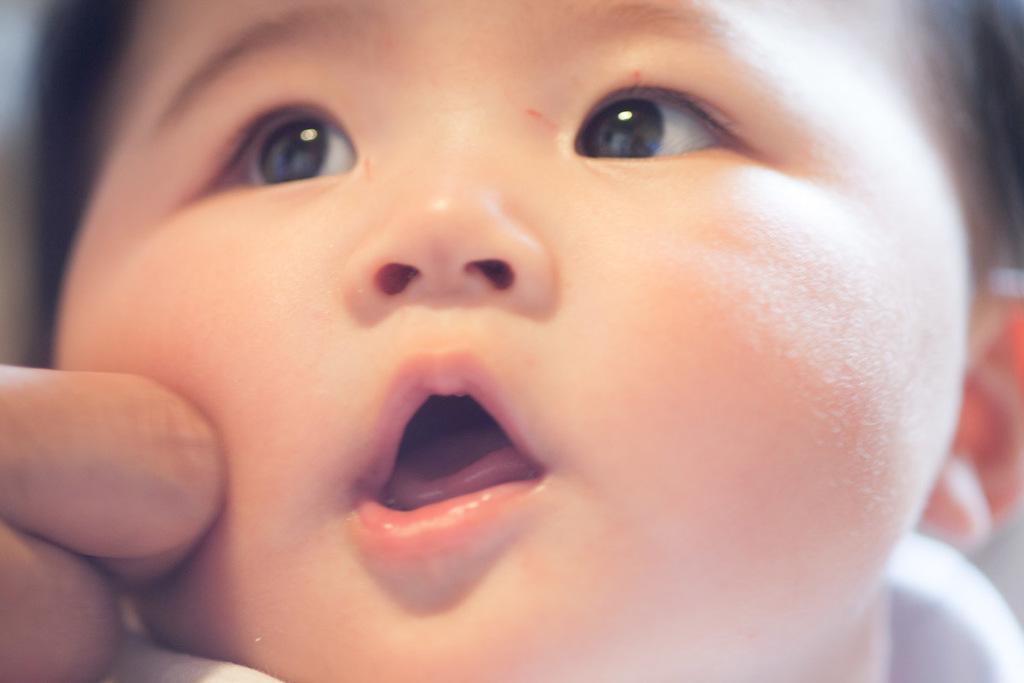Can you describe this image briefly? This image consists of small kid. To the left, there is a person fingers. 